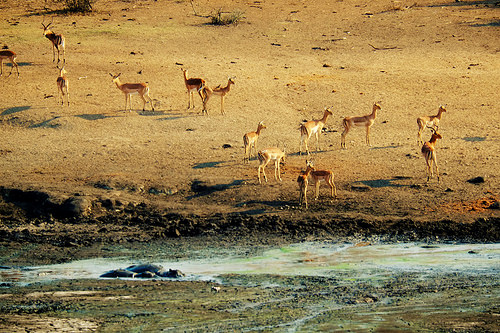<image>
Can you confirm if the deer is in the water? No. The deer is not contained within the water. These objects have a different spatial relationship. Is there a deer above the water? No. The deer is not positioned above the water. The vertical arrangement shows a different relationship. 